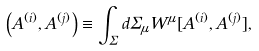Convert formula to latex. <formula><loc_0><loc_0><loc_500><loc_500>\left ( A ^ { ( i ) } , A ^ { ( j ) } \right ) \equiv \int _ { \Sigma } d \Sigma _ { \mu } W ^ { \mu } [ A ^ { ( i ) } , A ^ { ( j ) } ] ,</formula> 